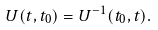<formula> <loc_0><loc_0><loc_500><loc_500>U ( t , t _ { 0 } ) = U ^ { - 1 } ( t _ { 0 } , t ) .</formula> 